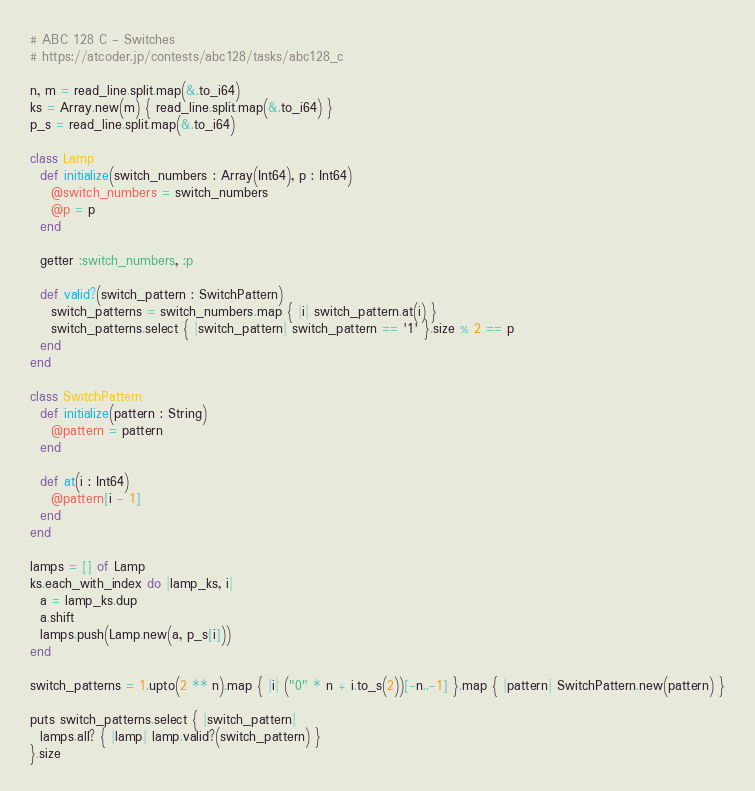Convert code to text. <code><loc_0><loc_0><loc_500><loc_500><_Crystal_># ABC 128 C - Switches
# https://atcoder.jp/contests/abc128/tasks/abc128_c

n, m = read_line.split.map(&.to_i64)
ks = Array.new(m) { read_line.split.map(&.to_i64) }
p_s = read_line.split.map(&.to_i64)

class Lamp
  def initialize(switch_numbers : Array(Int64), p : Int64)
    @switch_numbers = switch_numbers
    @p = p
  end

  getter :switch_numbers, :p

  def valid?(switch_pattern : SwitchPattern)
    switch_patterns = switch_numbers.map { |i| switch_pattern.at(i) }
    switch_patterns.select { |switch_pattern| switch_pattern == '1' }.size % 2 == p
  end
end

class SwitchPattern
  def initialize(pattern : String)
    @pattern = pattern
  end

  def at(i : Int64)
    @pattern[i - 1]
  end
end

lamps = [] of Lamp
ks.each_with_index do |lamp_ks, i|
  a = lamp_ks.dup
  a.shift
  lamps.push(Lamp.new(a, p_s[i]))
end

switch_patterns = 1.upto(2 ** n).map { |i| ("0" * n + i.to_s(2))[-n..-1] }.map { |pattern| SwitchPattern.new(pattern) }

puts switch_patterns.select { |switch_pattern|
  lamps.all? { |lamp| lamp.valid?(switch_pattern) }
}.size
</code> 